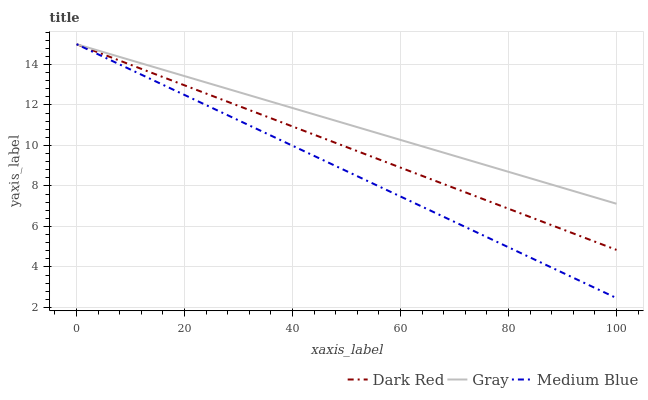Does Medium Blue have the minimum area under the curve?
Answer yes or no. Yes. Does Gray have the maximum area under the curve?
Answer yes or no. Yes. Does Gray have the minimum area under the curve?
Answer yes or no. No. Does Medium Blue have the maximum area under the curve?
Answer yes or no. No. Is Gray the smoothest?
Answer yes or no. Yes. Is Dark Red the roughest?
Answer yes or no. Yes. Is Medium Blue the smoothest?
Answer yes or no. No. Is Medium Blue the roughest?
Answer yes or no. No. Does Medium Blue have the lowest value?
Answer yes or no. Yes. Does Gray have the lowest value?
Answer yes or no. No. Does Gray have the highest value?
Answer yes or no. Yes. Does Gray intersect Dark Red?
Answer yes or no. Yes. Is Gray less than Dark Red?
Answer yes or no. No. Is Gray greater than Dark Red?
Answer yes or no. No. 